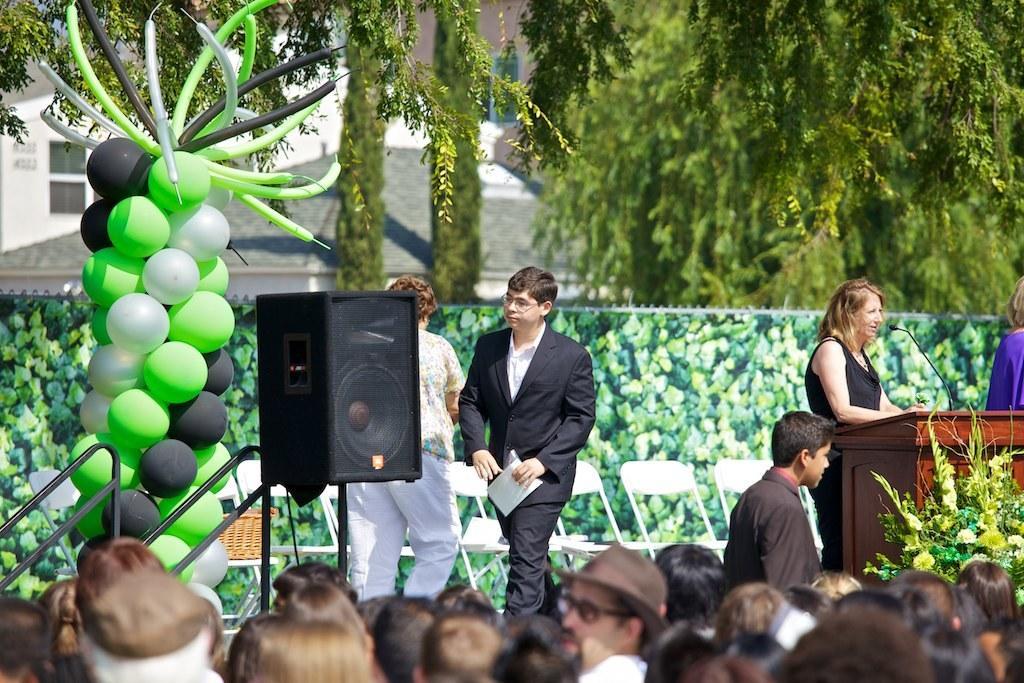In one or two sentences, can you explain what this image depicts? In this picture I can see there are a few people standing on the dais and there is a woman standing at the podium at right side, there is another person at the right side. There are balloons, speaker, wall in the backdrop, few people in front of the stage. In the backdrop, there are trees and buildings. 